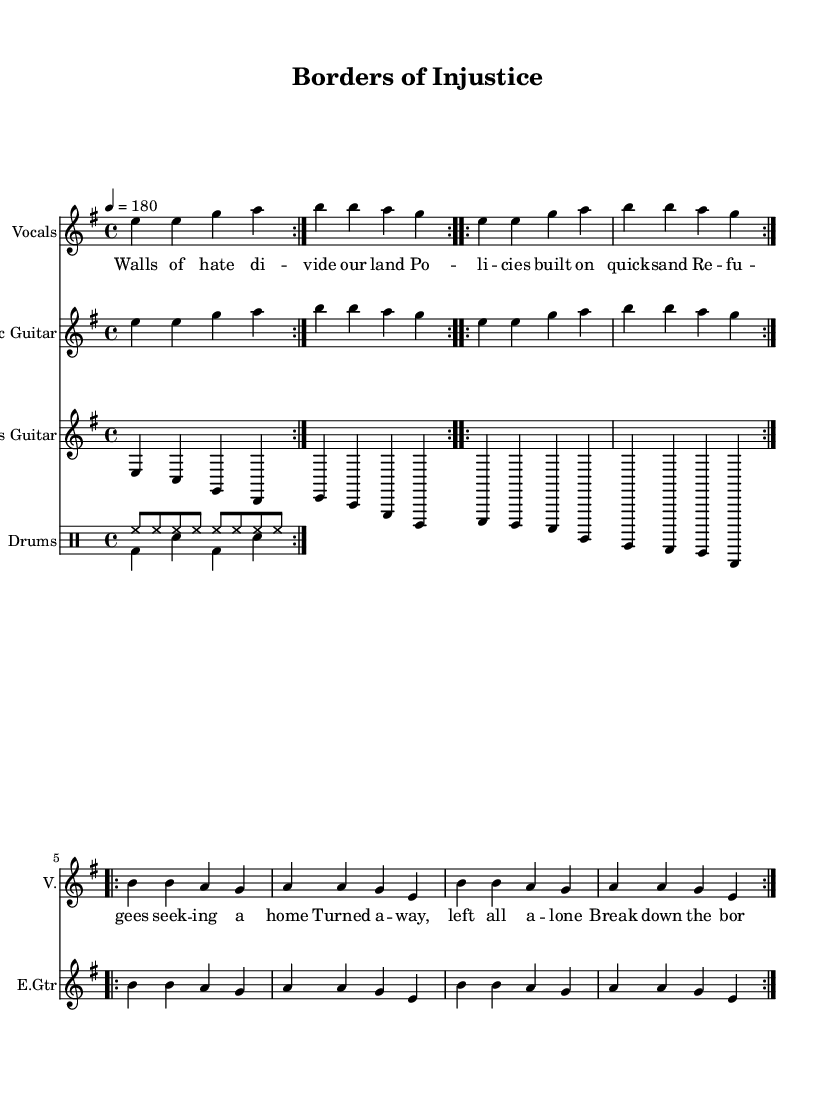What is the key signature of this music? The key signature is E minor, which has one sharp (F#) and indicates that the piece is primarily based on the E minor scale.
Answer: E minor What is the time signature of this music? The time signature, indicated at the beginning of the score, is 4/4, meaning there are four beats in each measure and the quarter note gets one beat.
Answer: 4/4 What is the tempo marking for this piece? The tempo marking is specified at a quarter note equals 180, indicating a fast tempo, typical of punk music.
Answer: 180 How many measures are in the verse section? By counting the measures in the verse part of the sheet music notation, we see there are four measures.
Answer: 4 What musical instruments are involved in this piece? The score includes an electric guitar, bass guitar, vocals, and drums, showcasing the typical instrumentation for a punk song.
Answer: Electric guitar, bass guitar, vocals, drums Which part of the song emphasizes social injustice? The lyrics in the chorus highlight the call to "Break down the borders of injustice," emphasizing the theme of social injustice.
Answer: Break down the borders of injustice What type of song structure is used in this piece? The song structure consists of verses followed by a chorus, reflecting a common structure in punk music where verses present a narrative followed by a repeated message in the chorus.
Answer: Verse-Chorus 